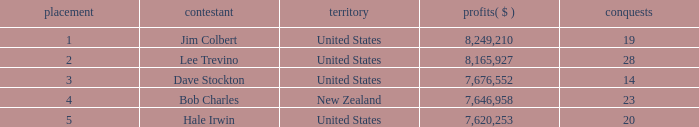How many players named bob charles with earnings over $7,646,958? 0.0. 